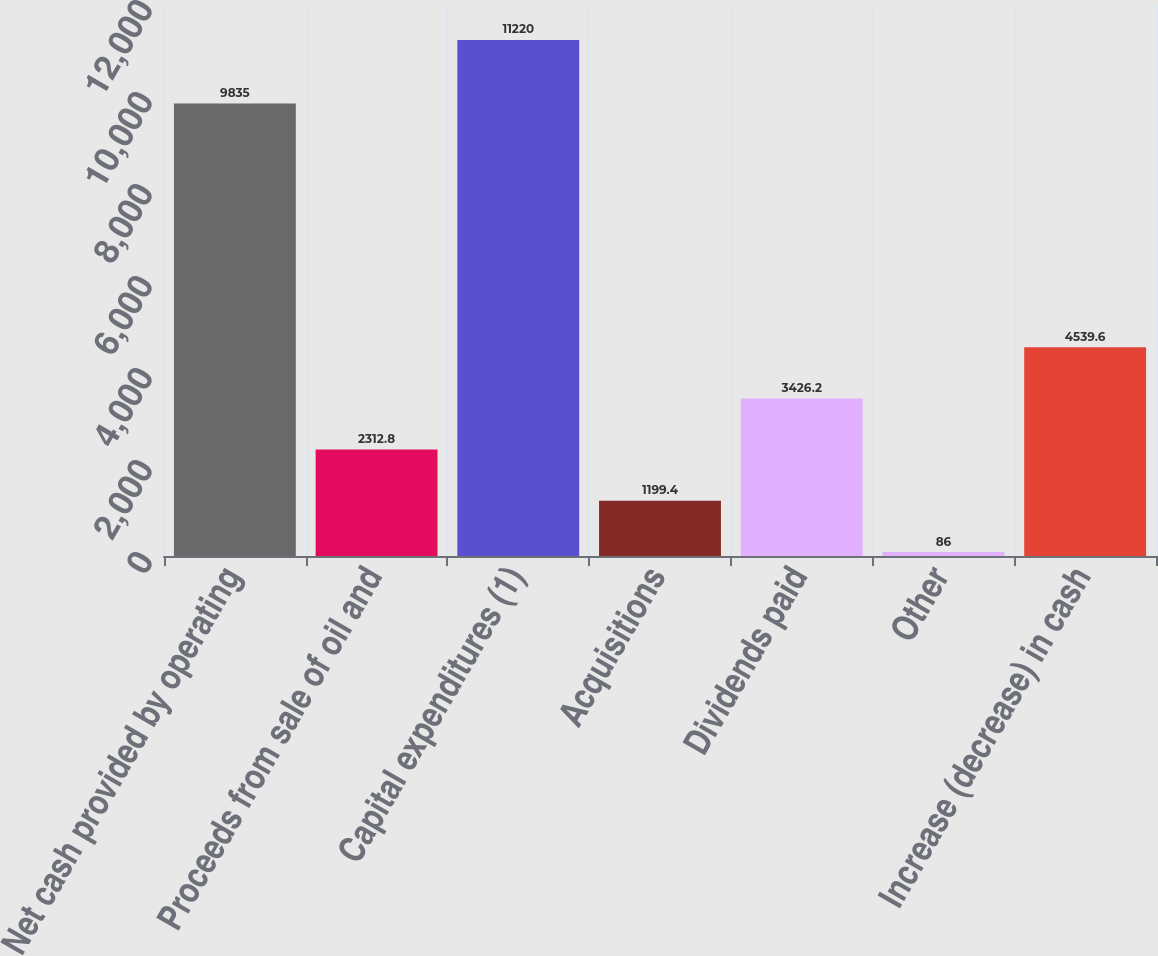Convert chart. <chart><loc_0><loc_0><loc_500><loc_500><bar_chart><fcel>Net cash provided by operating<fcel>Proceeds from sale of oil and<fcel>Capital expenditures (1)<fcel>Acquisitions<fcel>Dividends paid<fcel>Other<fcel>Increase (decrease) in cash<nl><fcel>9835<fcel>2312.8<fcel>11220<fcel>1199.4<fcel>3426.2<fcel>86<fcel>4539.6<nl></chart> 